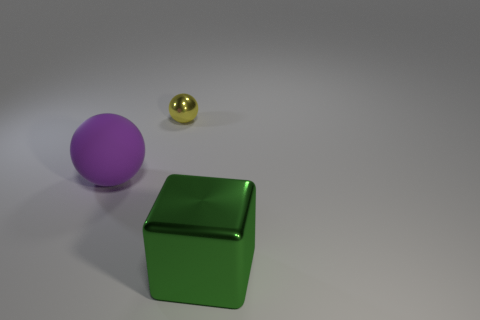Add 1 small metal things. How many objects exist? 4 Subtract all blocks. How many objects are left? 2 Add 1 yellow shiny spheres. How many yellow shiny spheres are left? 2 Add 3 small brown shiny things. How many small brown shiny things exist? 3 Subtract 0 cyan balls. How many objects are left? 3 Subtract all big green shiny spheres. Subtract all balls. How many objects are left? 1 